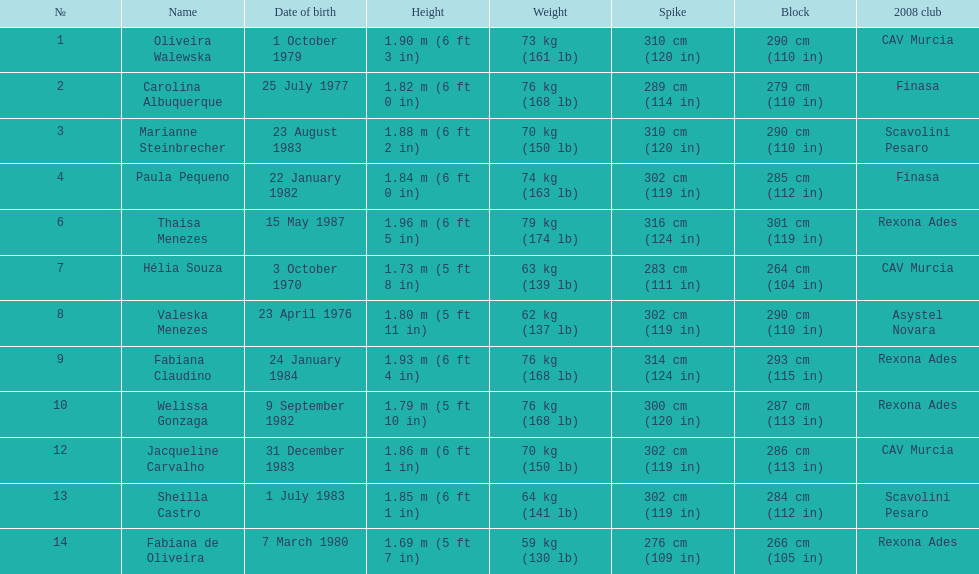Who is the shortest player, measuring only 5 ft 7 in tall? Fabiana de Oliveira. 